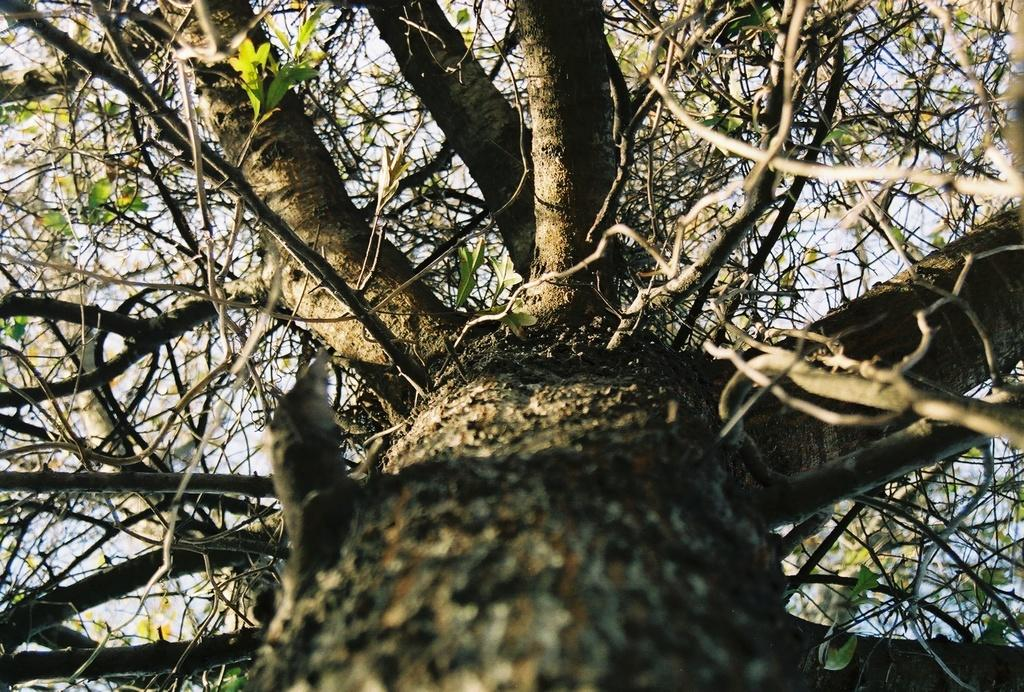What is the main feature of the image? There is a big tree in the image. Can you describe the tree in more detail? Unfortunately, the provided facts do not give any additional details about the tree. Is there anything else visible in the image besides the tree? The facts do not mention any other objects or features in the image. What type of van is parked next to the tree in the image? There is no van present in the image; it only features a big tree. How many needles are visible on the tree in the image? The facts do not mention any specific details about the tree, such as its type or characteristics, so it is impossible to determine the number of needles. 